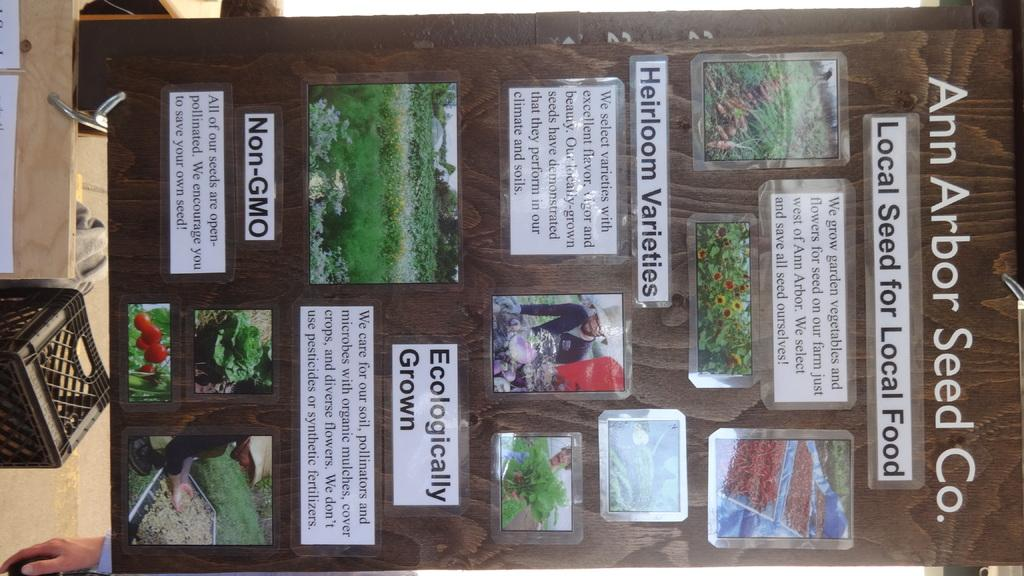<image>
Share a concise interpretation of the image provided. The words Ecologically Grown are on a board. 